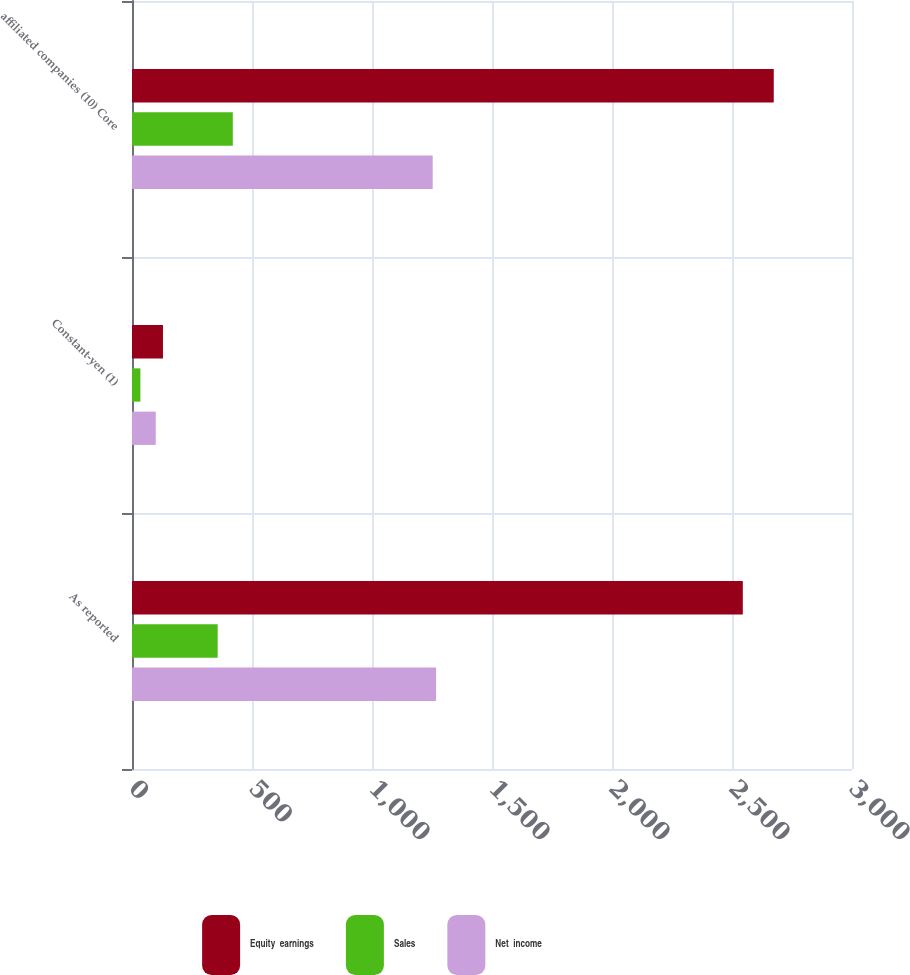Convert chart to OTSL. <chart><loc_0><loc_0><loc_500><loc_500><stacked_bar_chart><ecel><fcel>As reported<fcel>Constant-yen (1)<fcel>affiliated companies (10) Core<nl><fcel>Equity  earnings<fcel>2545<fcel>129<fcel>2674<nl><fcel>Sales<fcel>357<fcel>35<fcel>420<nl><fcel>Net  income<fcel>1267<fcel>99<fcel>1253<nl></chart> 